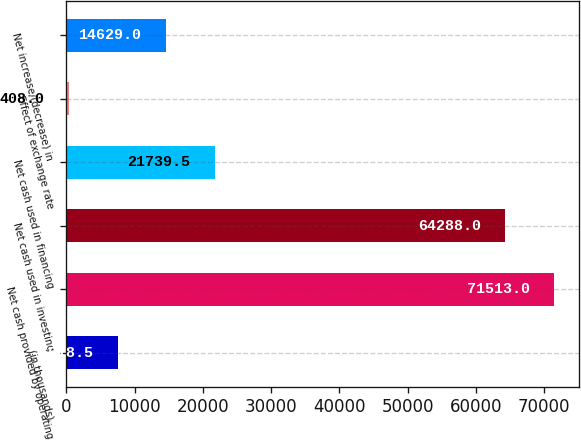<chart> <loc_0><loc_0><loc_500><loc_500><bar_chart><fcel>(in thousands)<fcel>Net cash provided by operating<fcel>Net cash used in investing<fcel>Net cash used in financing<fcel>Effect of exchange rate<fcel>Net increase/(decrease) in<nl><fcel>7518.5<fcel>71513<fcel>64288<fcel>21739.5<fcel>408<fcel>14629<nl></chart> 